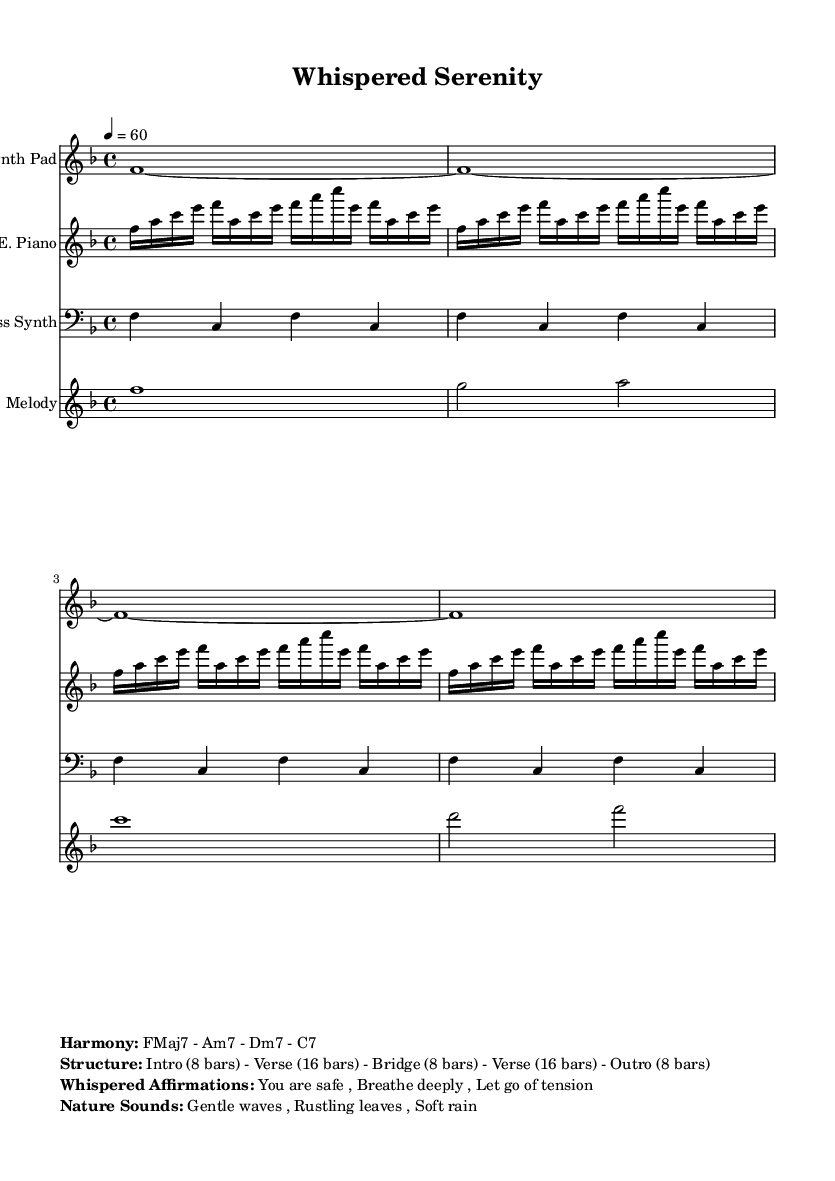What is the key signature of this music? The key signature indicated in the global section is F major, which has one flat (B flat).
Answer: F major What is the time signature of this piece? The time signature shown in the global section is 4/4, meaning there are four beats per measure.
Answer: 4/4 What is the tempo marking for this composition? The tempo specified is 60 beats per minute, as noted in the global section.
Answer: 60 How many bars are there in the intro? The structure section states that the intro consists of 8 bars.
Answer: 8 bars What chord progression is used in the harmony? The harmony section lists the chords as FMaj7 - Am7 - Dm7 - C7, which outlines the harmonic landscape of the piece.
Answer: FMaj7 - Am7 - Dm7 - C7 What sounds accompany the whispered affirmations? The nature sounds that accompany the affirmations include gentle waves, rustling leaves, and soft rain, which create a calming atmosphere.
Answer: Gentle waves, rustling leaves, soft rain What is the structure of the music? The music structure is defined as Intro - Verse - Bridge - Verse - Outro, with the respective bar counts listed in the structure section.
Answer: Intro (8 bars) - Verse (16 bars) - Bridge (8 bars) - Verse (16 bars) - Outro (8 bars) 